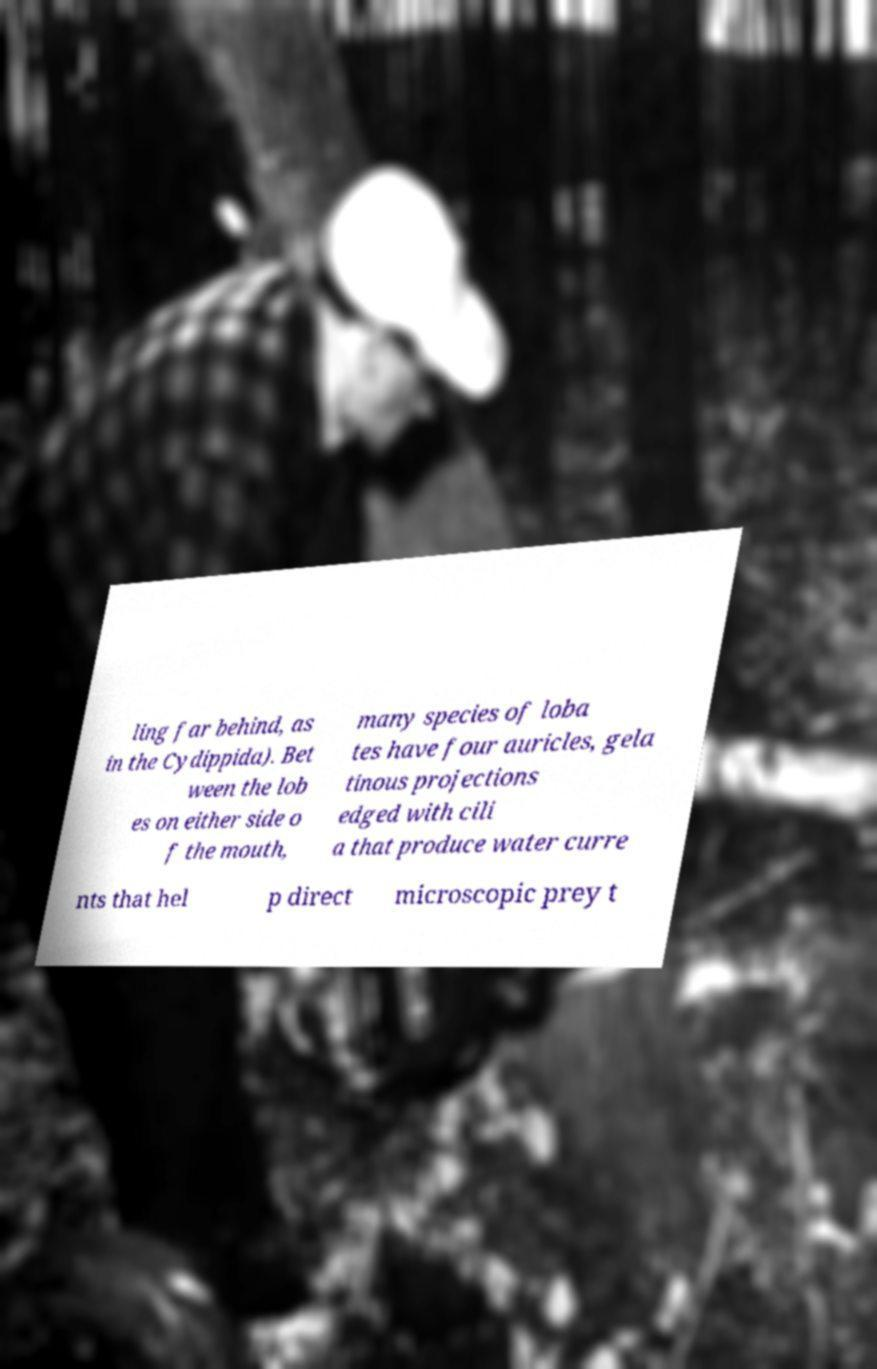Could you extract and type out the text from this image? ling far behind, as in the Cydippida). Bet ween the lob es on either side o f the mouth, many species of loba tes have four auricles, gela tinous projections edged with cili a that produce water curre nts that hel p direct microscopic prey t 